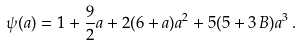Convert formula to latex. <formula><loc_0><loc_0><loc_500><loc_500>\psi ( a ) = 1 + \frac { 9 } { 2 } a + 2 ( 6 + a ) a ^ { 2 } + 5 ( 5 + 3 \, B ) a ^ { 3 } \, .</formula> 